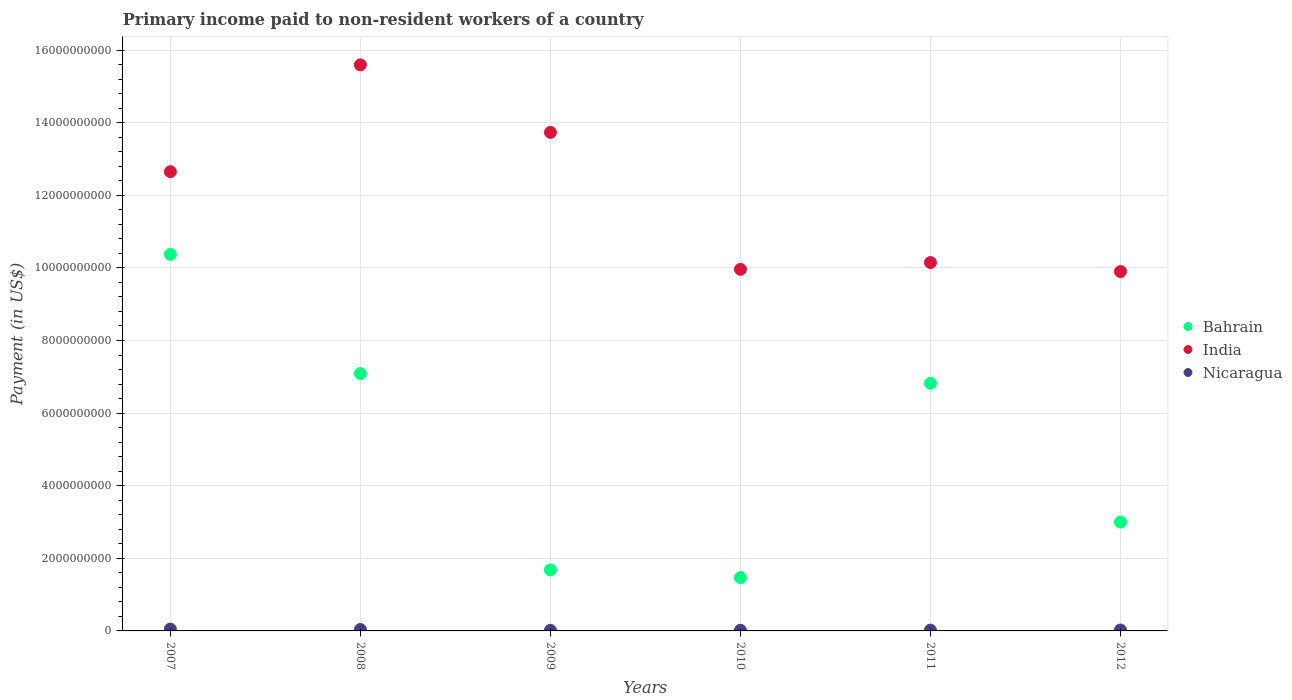What is the amount paid to workers in India in 2010?
Keep it short and to the point. 9.96e+09. Across all years, what is the maximum amount paid to workers in India?
Give a very brief answer. 1.56e+1. Across all years, what is the minimum amount paid to workers in India?
Keep it short and to the point. 9.90e+09. What is the total amount paid to workers in Bahrain in the graph?
Your answer should be very brief. 3.04e+1. What is the difference between the amount paid to workers in Bahrain in 2007 and that in 2011?
Give a very brief answer. 3.55e+09. What is the difference between the amount paid to workers in Nicaragua in 2011 and the amount paid to workers in India in 2010?
Offer a very short reply. -9.94e+09. What is the average amount paid to workers in India per year?
Offer a very short reply. 1.20e+1. In the year 2009, what is the difference between the amount paid to workers in Nicaragua and amount paid to workers in Bahrain?
Offer a terse response. -1.66e+09. In how many years, is the amount paid to workers in Bahrain greater than 5200000000 US$?
Give a very brief answer. 3. What is the ratio of the amount paid to workers in India in 2010 to that in 2011?
Give a very brief answer. 0.98. Is the amount paid to workers in Bahrain in 2010 less than that in 2011?
Provide a succinct answer. Yes. What is the difference between the highest and the second highest amount paid to workers in Nicaragua?
Ensure brevity in your answer.  9.20e+06. What is the difference between the highest and the lowest amount paid to workers in India?
Ensure brevity in your answer.  5.69e+09. In how many years, is the amount paid to workers in India greater than the average amount paid to workers in India taken over all years?
Offer a terse response. 3. Is the sum of the amount paid to workers in India in 2009 and 2011 greater than the maximum amount paid to workers in Bahrain across all years?
Keep it short and to the point. Yes. Does the amount paid to workers in Bahrain monotonically increase over the years?
Keep it short and to the point. No. Is the amount paid to workers in India strictly greater than the amount paid to workers in Nicaragua over the years?
Make the answer very short. Yes. Is the amount paid to workers in Bahrain strictly less than the amount paid to workers in Nicaragua over the years?
Offer a very short reply. No. How many dotlines are there?
Keep it short and to the point. 3. How many years are there in the graph?
Keep it short and to the point. 6. Are the values on the major ticks of Y-axis written in scientific E-notation?
Your answer should be compact. No. Where does the legend appear in the graph?
Your answer should be very brief. Center right. What is the title of the graph?
Provide a succinct answer. Primary income paid to non-resident workers of a country. What is the label or title of the X-axis?
Provide a succinct answer. Years. What is the label or title of the Y-axis?
Make the answer very short. Payment (in US$). What is the Payment (in US$) of Bahrain in 2007?
Make the answer very short. 1.04e+1. What is the Payment (in US$) in India in 2007?
Your response must be concise. 1.26e+1. What is the Payment (in US$) in Nicaragua in 2007?
Ensure brevity in your answer.  4.96e+07. What is the Payment (in US$) of Bahrain in 2008?
Give a very brief answer. 7.09e+09. What is the Payment (in US$) in India in 2008?
Offer a terse response. 1.56e+1. What is the Payment (in US$) in Nicaragua in 2008?
Provide a short and direct response. 4.04e+07. What is the Payment (in US$) of Bahrain in 2009?
Ensure brevity in your answer.  1.68e+09. What is the Payment (in US$) of India in 2009?
Provide a succinct answer. 1.37e+1. What is the Payment (in US$) of Nicaragua in 2009?
Make the answer very short. 1.73e+07. What is the Payment (in US$) of Bahrain in 2010?
Ensure brevity in your answer.  1.47e+09. What is the Payment (in US$) in India in 2010?
Provide a short and direct response. 9.96e+09. What is the Payment (in US$) in Nicaragua in 2010?
Keep it short and to the point. 1.82e+07. What is the Payment (in US$) of Bahrain in 2011?
Provide a short and direct response. 6.82e+09. What is the Payment (in US$) of India in 2011?
Your answer should be very brief. 1.01e+1. What is the Payment (in US$) of Nicaragua in 2011?
Provide a succinct answer. 2.16e+07. What is the Payment (in US$) of Bahrain in 2012?
Keep it short and to the point. 3.00e+09. What is the Payment (in US$) of India in 2012?
Your answer should be very brief. 9.90e+09. What is the Payment (in US$) in Nicaragua in 2012?
Your answer should be compact. 2.52e+07. Across all years, what is the maximum Payment (in US$) of Bahrain?
Give a very brief answer. 1.04e+1. Across all years, what is the maximum Payment (in US$) of India?
Your response must be concise. 1.56e+1. Across all years, what is the maximum Payment (in US$) in Nicaragua?
Provide a short and direct response. 4.96e+07. Across all years, what is the minimum Payment (in US$) of Bahrain?
Make the answer very short. 1.47e+09. Across all years, what is the minimum Payment (in US$) in India?
Your response must be concise. 9.90e+09. Across all years, what is the minimum Payment (in US$) of Nicaragua?
Your answer should be compact. 1.73e+07. What is the total Payment (in US$) in Bahrain in the graph?
Provide a short and direct response. 3.04e+1. What is the total Payment (in US$) in India in the graph?
Provide a short and direct response. 7.20e+1. What is the total Payment (in US$) of Nicaragua in the graph?
Your answer should be very brief. 1.72e+08. What is the difference between the Payment (in US$) in Bahrain in 2007 and that in 2008?
Make the answer very short. 3.29e+09. What is the difference between the Payment (in US$) in India in 2007 and that in 2008?
Your answer should be very brief. -2.94e+09. What is the difference between the Payment (in US$) of Nicaragua in 2007 and that in 2008?
Your answer should be compact. 9.20e+06. What is the difference between the Payment (in US$) of Bahrain in 2007 and that in 2009?
Ensure brevity in your answer.  8.69e+09. What is the difference between the Payment (in US$) in India in 2007 and that in 2009?
Offer a terse response. -1.08e+09. What is the difference between the Payment (in US$) in Nicaragua in 2007 and that in 2009?
Provide a short and direct response. 3.23e+07. What is the difference between the Payment (in US$) of Bahrain in 2007 and that in 2010?
Ensure brevity in your answer.  8.91e+09. What is the difference between the Payment (in US$) in India in 2007 and that in 2010?
Keep it short and to the point. 2.69e+09. What is the difference between the Payment (in US$) in Nicaragua in 2007 and that in 2010?
Your answer should be compact. 3.14e+07. What is the difference between the Payment (in US$) in Bahrain in 2007 and that in 2011?
Provide a succinct answer. 3.55e+09. What is the difference between the Payment (in US$) in India in 2007 and that in 2011?
Keep it short and to the point. 2.50e+09. What is the difference between the Payment (in US$) of Nicaragua in 2007 and that in 2011?
Make the answer very short. 2.80e+07. What is the difference between the Payment (in US$) of Bahrain in 2007 and that in 2012?
Provide a short and direct response. 7.38e+09. What is the difference between the Payment (in US$) in India in 2007 and that in 2012?
Offer a very short reply. 2.75e+09. What is the difference between the Payment (in US$) of Nicaragua in 2007 and that in 2012?
Your answer should be very brief. 2.44e+07. What is the difference between the Payment (in US$) of Bahrain in 2008 and that in 2009?
Keep it short and to the point. 5.41e+09. What is the difference between the Payment (in US$) of India in 2008 and that in 2009?
Your response must be concise. 1.86e+09. What is the difference between the Payment (in US$) in Nicaragua in 2008 and that in 2009?
Give a very brief answer. 2.31e+07. What is the difference between the Payment (in US$) of Bahrain in 2008 and that in 2010?
Offer a terse response. 5.62e+09. What is the difference between the Payment (in US$) in India in 2008 and that in 2010?
Provide a succinct answer. 5.63e+09. What is the difference between the Payment (in US$) in Nicaragua in 2008 and that in 2010?
Ensure brevity in your answer.  2.22e+07. What is the difference between the Payment (in US$) of Bahrain in 2008 and that in 2011?
Make the answer very short. 2.66e+08. What is the difference between the Payment (in US$) of India in 2008 and that in 2011?
Make the answer very short. 5.45e+09. What is the difference between the Payment (in US$) in Nicaragua in 2008 and that in 2011?
Make the answer very short. 1.88e+07. What is the difference between the Payment (in US$) in Bahrain in 2008 and that in 2012?
Keep it short and to the point. 4.09e+09. What is the difference between the Payment (in US$) in India in 2008 and that in 2012?
Provide a short and direct response. 5.69e+09. What is the difference between the Payment (in US$) in Nicaragua in 2008 and that in 2012?
Offer a terse response. 1.52e+07. What is the difference between the Payment (in US$) of Bahrain in 2009 and that in 2010?
Provide a short and direct response. 2.13e+08. What is the difference between the Payment (in US$) of India in 2009 and that in 2010?
Offer a terse response. 3.77e+09. What is the difference between the Payment (in US$) of Nicaragua in 2009 and that in 2010?
Your answer should be very brief. -9.00e+05. What is the difference between the Payment (in US$) in Bahrain in 2009 and that in 2011?
Offer a very short reply. -5.14e+09. What is the difference between the Payment (in US$) of India in 2009 and that in 2011?
Your answer should be compact. 3.59e+09. What is the difference between the Payment (in US$) of Nicaragua in 2009 and that in 2011?
Ensure brevity in your answer.  -4.30e+06. What is the difference between the Payment (in US$) of Bahrain in 2009 and that in 2012?
Offer a terse response. -1.32e+09. What is the difference between the Payment (in US$) in India in 2009 and that in 2012?
Provide a succinct answer. 3.83e+09. What is the difference between the Payment (in US$) of Nicaragua in 2009 and that in 2012?
Your answer should be very brief. -7.90e+06. What is the difference between the Payment (in US$) of Bahrain in 2010 and that in 2011?
Provide a succinct answer. -5.35e+09. What is the difference between the Payment (in US$) in India in 2010 and that in 2011?
Provide a succinct answer. -1.86e+08. What is the difference between the Payment (in US$) of Nicaragua in 2010 and that in 2011?
Ensure brevity in your answer.  -3.40e+06. What is the difference between the Payment (in US$) in Bahrain in 2010 and that in 2012?
Make the answer very short. -1.53e+09. What is the difference between the Payment (in US$) in India in 2010 and that in 2012?
Offer a terse response. 6.21e+07. What is the difference between the Payment (in US$) in Nicaragua in 2010 and that in 2012?
Keep it short and to the point. -7.00e+06. What is the difference between the Payment (in US$) of Bahrain in 2011 and that in 2012?
Your answer should be compact. 3.82e+09. What is the difference between the Payment (in US$) of India in 2011 and that in 2012?
Provide a short and direct response. 2.48e+08. What is the difference between the Payment (in US$) of Nicaragua in 2011 and that in 2012?
Your response must be concise. -3.60e+06. What is the difference between the Payment (in US$) of Bahrain in 2007 and the Payment (in US$) of India in 2008?
Your answer should be compact. -5.22e+09. What is the difference between the Payment (in US$) of Bahrain in 2007 and the Payment (in US$) of Nicaragua in 2008?
Offer a very short reply. 1.03e+1. What is the difference between the Payment (in US$) in India in 2007 and the Payment (in US$) in Nicaragua in 2008?
Your response must be concise. 1.26e+1. What is the difference between the Payment (in US$) in Bahrain in 2007 and the Payment (in US$) in India in 2009?
Keep it short and to the point. -3.36e+09. What is the difference between the Payment (in US$) in Bahrain in 2007 and the Payment (in US$) in Nicaragua in 2009?
Offer a terse response. 1.04e+1. What is the difference between the Payment (in US$) in India in 2007 and the Payment (in US$) in Nicaragua in 2009?
Your answer should be very brief. 1.26e+1. What is the difference between the Payment (in US$) of Bahrain in 2007 and the Payment (in US$) of India in 2010?
Offer a very short reply. 4.13e+08. What is the difference between the Payment (in US$) of Bahrain in 2007 and the Payment (in US$) of Nicaragua in 2010?
Offer a terse response. 1.04e+1. What is the difference between the Payment (in US$) of India in 2007 and the Payment (in US$) of Nicaragua in 2010?
Offer a very short reply. 1.26e+1. What is the difference between the Payment (in US$) of Bahrain in 2007 and the Payment (in US$) of India in 2011?
Ensure brevity in your answer.  2.26e+08. What is the difference between the Payment (in US$) of Bahrain in 2007 and the Payment (in US$) of Nicaragua in 2011?
Your answer should be very brief. 1.04e+1. What is the difference between the Payment (in US$) in India in 2007 and the Payment (in US$) in Nicaragua in 2011?
Offer a terse response. 1.26e+1. What is the difference between the Payment (in US$) in Bahrain in 2007 and the Payment (in US$) in India in 2012?
Offer a terse response. 4.75e+08. What is the difference between the Payment (in US$) of Bahrain in 2007 and the Payment (in US$) of Nicaragua in 2012?
Your answer should be compact. 1.03e+1. What is the difference between the Payment (in US$) in India in 2007 and the Payment (in US$) in Nicaragua in 2012?
Offer a terse response. 1.26e+1. What is the difference between the Payment (in US$) of Bahrain in 2008 and the Payment (in US$) of India in 2009?
Make the answer very short. -6.64e+09. What is the difference between the Payment (in US$) in Bahrain in 2008 and the Payment (in US$) in Nicaragua in 2009?
Your response must be concise. 7.07e+09. What is the difference between the Payment (in US$) in India in 2008 and the Payment (in US$) in Nicaragua in 2009?
Offer a very short reply. 1.56e+1. What is the difference between the Payment (in US$) in Bahrain in 2008 and the Payment (in US$) in India in 2010?
Keep it short and to the point. -2.87e+09. What is the difference between the Payment (in US$) in Bahrain in 2008 and the Payment (in US$) in Nicaragua in 2010?
Your response must be concise. 7.07e+09. What is the difference between the Payment (in US$) in India in 2008 and the Payment (in US$) in Nicaragua in 2010?
Offer a very short reply. 1.56e+1. What is the difference between the Payment (in US$) in Bahrain in 2008 and the Payment (in US$) in India in 2011?
Your response must be concise. -3.06e+09. What is the difference between the Payment (in US$) in Bahrain in 2008 and the Payment (in US$) in Nicaragua in 2011?
Make the answer very short. 7.07e+09. What is the difference between the Payment (in US$) in India in 2008 and the Payment (in US$) in Nicaragua in 2011?
Offer a very short reply. 1.56e+1. What is the difference between the Payment (in US$) in Bahrain in 2008 and the Payment (in US$) in India in 2012?
Provide a succinct answer. -2.81e+09. What is the difference between the Payment (in US$) in Bahrain in 2008 and the Payment (in US$) in Nicaragua in 2012?
Your answer should be very brief. 7.06e+09. What is the difference between the Payment (in US$) of India in 2008 and the Payment (in US$) of Nicaragua in 2012?
Offer a very short reply. 1.56e+1. What is the difference between the Payment (in US$) in Bahrain in 2009 and the Payment (in US$) in India in 2010?
Offer a very short reply. -8.28e+09. What is the difference between the Payment (in US$) in Bahrain in 2009 and the Payment (in US$) in Nicaragua in 2010?
Offer a very short reply. 1.66e+09. What is the difference between the Payment (in US$) of India in 2009 and the Payment (in US$) of Nicaragua in 2010?
Provide a short and direct response. 1.37e+1. What is the difference between the Payment (in US$) in Bahrain in 2009 and the Payment (in US$) in India in 2011?
Your response must be concise. -8.47e+09. What is the difference between the Payment (in US$) in Bahrain in 2009 and the Payment (in US$) in Nicaragua in 2011?
Ensure brevity in your answer.  1.66e+09. What is the difference between the Payment (in US$) of India in 2009 and the Payment (in US$) of Nicaragua in 2011?
Provide a short and direct response. 1.37e+1. What is the difference between the Payment (in US$) in Bahrain in 2009 and the Payment (in US$) in India in 2012?
Your answer should be very brief. -8.22e+09. What is the difference between the Payment (in US$) of Bahrain in 2009 and the Payment (in US$) of Nicaragua in 2012?
Your answer should be very brief. 1.65e+09. What is the difference between the Payment (in US$) of India in 2009 and the Payment (in US$) of Nicaragua in 2012?
Your answer should be very brief. 1.37e+1. What is the difference between the Payment (in US$) of Bahrain in 2010 and the Payment (in US$) of India in 2011?
Offer a very short reply. -8.68e+09. What is the difference between the Payment (in US$) in Bahrain in 2010 and the Payment (in US$) in Nicaragua in 2011?
Provide a succinct answer. 1.45e+09. What is the difference between the Payment (in US$) of India in 2010 and the Payment (in US$) of Nicaragua in 2011?
Ensure brevity in your answer.  9.94e+09. What is the difference between the Payment (in US$) in Bahrain in 2010 and the Payment (in US$) in India in 2012?
Provide a succinct answer. -8.43e+09. What is the difference between the Payment (in US$) of Bahrain in 2010 and the Payment (in US$) of Nicaragua in 2012?
Provide a short and direct response. 1.44e+09. What is the difference between the Payment (in US$) of India in 2010 and the Payment (in US$) of Nicaragua in 2012?
Ensure brevity in your answer.  9.94e+09. What is the difference between the Payment (in US$) of Bahrain in 2011 and the Payment (in US$) of India in 2012?
Your answer should be very brief. -3.08e+09. What is the difference between the Payment (in US$) in Bahrain in 2011 and the Payment (in US$) in Nicaragua in 2012?
Your answer should be compact. 6.80e+09. What is the difference between the Payment (in US$) in India in 2011 and the Payment (in US$) in Nicaragua in 2012?
Provide a short and direct response. 1.01e+1. What is the average Payment (in US$) in Bahrain per year?
Your answer should be very brief. 5.07e+09. What is the average Payment (in US$) in India per year?
Ensure brevity in your answer.  1.20e+1. What is the average Payment (in US$) of Nicaragua per year?
Make the answer very short. 2.87e+07. In the year 2007, what is the difference between the Payment (in US$) of Bahrain and Payment (in US$) of India?
Ensure brevity in your answer.  -2.28e+09. In the year 2007, what is the difference between the Payment (in US$) in Bahrain and Payment (in US$) in Nicaragua?
Your answer should be very brief. 1.03e+1. In the year 2007, what is the difference between the Payment (in US$) in India and Payment (in US$) in Nicaragua?
Offer a very short reply. 1.26e+1. In the year 2008, what is the difference between the Payment (in US$) in Bahrain and Payment (in US$) in India?
Your answer should be very brief. -8.51e+09. In the year 2008, what is the difference between the Payment (in US$) in Bahrain and Payment (in US$) in Nicaragua?
Make the answer very short. 7.05e+09. In the year 2008, what is the difference between the Payment (in US$) in India and Payment (in US$) in Nicaragua?
Offer a terse response. 1.56e+1. In the year 2009, what is the difference between the Payment (in US$) of Bahrain and Payment (in US$) of India?
Make the answer very short. -1.21e+1. In the year 2009, what is the difference between the Payment (in US$) in Bahrain and Payment (in US$) in Nicaragua?
Your answer should be compact. 1.66e+09. In the year 2009, what is the difference between the Payment (in US$) of India and Payment (in US$) of Nicaragua?
Provide a short and direct response. 1.37e+1. In the year 2010, what is the difference between the Payment (in US$) in Bahrain and Payment (in US$) in India?
Make the answer very short. -8.49e+09. In the year 2010, what is the difference between the Payment (in US$) of Bahrain and Payment (in US$) of Nicaragua?
Your answer should be compact. 1.45e+09. In the year 2010, what is the difference between the Payment (in US$) in India and Payment (in US$) in Nicaragua?
Ensure brevity in your answer.  9.94e+09. In the year 2011, what is the difference between the Payment (in US$) in Bahrain and Payment (in US$) in India?
Make the answer very short. -3.33e+09. In the year 2011, what is the difference between the Payment (in US$) in Bahrain and Payment (in US$) in Nicaragua?
Offer a very short reply. 6.80e+09. In the year 2011, what is the difference between the Payment (in US$) in India and Payment (in US$) in Nicaragua?
Your response must be concise. 1.01e+1. In the year 2012, what is the difference between the Payment (in US$) of Bahrain and Payment (in US$) of India?
Make the answer very short. -6.90e+09. In the year 2012, what is the difference between the Payment (in US$) in Bahrain and Payment (in US$) in Nicaragua?
Offer a terse response. 2.97e+09. In the year 2012, what is the difference between the Payment (in US$) of India and Payment (in US$) of Nicaragua?
Make the answer very short. 9.87e+09. What is the ratio of the Payment (in US$) of Bahrain in 2007 to that in 2008?
Provide a succinct answer. 1.46. What is the ratio of the Payment (in US$) in India in 2007 to that in 2008?
Your answer should be compact. 0.81. What is the ratio of the Payment (in US$) of Nicaragua in 2007 to that in 2008?
Offer a very short reply. 1.23. What is the ratio of the Payment (in US$) in Bahrain in 2007 to that in 2009?
Offer a terse response. 6.17. What is the ratio of the Payment (in US$) in India in 2007 to that in 2009?
Your answer should be very brief. 0.92. What is the ratio of the Payment (in US$) of Nicaragua in 2007 to that in 2009?
Provide a short and direct response. 2.87. What is the ratio of the Payment (in US$) in Bahrain in 2007 to that in 2010?
Make the answer very short. 7.07. What is the ratio of the Payment (in US$) in India in 2007 to that in 2010?
Offer a terse response. 1.27. What is the ratio of the Payment (in US$) of Nicaragua in 2007 to that in 2010?
Offer a terse response. 2.73. What is the ratio of the Payment (in US$) in Bahrain in 2007 to that in 2011?
Offer a very short reply. 1.52. What is the ratio of the Payment (in US$) in India in 2007 to that in 2011?
Your answer should be very brief. 1.25. What is the ratio of the Payment (in US$) of Nicaragua in 2007 to that in 2011?
Keep it short and to the point. 2.3. What is the ratio of the Payment (in US$) in Bahrain in 2007 to that in 2012?
Ensure brevity in your answer.  3.46. What is the ratio of the Payment (in US$) of India in 2007 to that in 2012?
Your answer should be compact. 1.28. What is the ratio of the Payment (in US$) of Nicaragua in 2007 to that in 2012?
Your answer should be very brief. 1.97. What is the ratio of the Payment (in US$) in Bahrain in 2008 to that in 2009?
Your answer should be very brief. 4.22. What is the ratio of the Payment (in US$) in India in 2008 to that in 2009?
Your answer should be compact. 1.14. What is the ratio of the Payment (in US$) of Nicaragua in 2008 to that in 2009?
Your response must be concise. 2.34. What is the ratio of the Payment (in US$) in Bahrain in 2008 to that in 2010?
Provide a succinct answer. 4.83. What is the ratio of the Payment (in US$) in India in 2008 to that in 2010?
Ensure brevity in your answer.  1.57. What is the ratio of the Payment (in US$) in Nicaragua in 2008 to that in 2010?
Offer a terse response. 2.22. What is the ratio of the Payment (in US$) in Bahrain in 2008 to that in 2011?
Your answer should be compact. 1.04. What is the ratio of the Payment (in US$) in India in 2008 to that in 2011?
Offer a very short reply. 1.54. What is the ratio of the Payment (in US$) of Nicaragua in 2008 to that in 2011?
Your response must be concise. 1.87. What is the ratio of the Payment (in US$) in Bahrain in 2008 to that in 2012?
Your response must be concise. 2.36. What is the ratio of the Payment (in US$) in India in 2008 to that in 2012?
Ensure brevity in your answer.  1.58. What is the ratio of the Payment (in US$) of Nicaragua in 2008 to that in 2012?
Ensure brevity in your answer.  1.6. What is the ratio of the Payment (in US$) of Bahrain in 2009 to that in 2010?
Provide a succinct answer. 1.14. What is the ratio of the Payment (in US$) of India in 2009 to that in 2010?
Your answer should be compact. 1.38. What is the ratio of the Payment (in US$) in Nicaragua in 2009 to that in 2010?
Keep it short and to the point. 0.95. What is the ratio of the Payment (in US$) in Bahrain in 2009 to that in 2011?
Provide a short and direct response. 0.25. What is the ratio of the Payment (in US$) of India in 2009 to that in 2011?
Your answer should be very brief. 1.35. What is the ratio of the Payment (in US$) in Nicaragua in 2009 to that in 2011?
Make the answer very short. 0.8. What is the ratio of the Payment (in US$) of Bahrain in 2009 to that in 2012?
Make the answer very short. 0.56. What is the ratio of the Payment (in US$) in India in 2009 to that in 2012?
Your response must be concise. 1.39. What is the ratio of the Payment (in US$) in Nicaragua in 2009 to that in 2012?
Your response must be concise. 0.69. What is the ratio of the Payment (in US$) in Bahrain in 2010 to that in 2011?
Keep it short and to the point. 0.22. What is the ratio of the Payment (in US$) of India in 2010 to that in 2011?
Provide a succinct answer. 0.98. What is the ratio of the Payment (in US$) in Nicaragua in 2010 to that in 2011?
Keep it short and to the point. 0.84. What is the ratio of the Payment (in US$) of Bahrain in 2010 to that in 2012?
Keep it short and to the point. 0.49. What is the ratio of the Payment (in US$) in India in 2010 to that in 2012?
Your response must be concise. 1.01. What is the ratio of the Payment (in US$) of Nicaragua in 2010 to that in 2012?
Make the answer very short. 0.72. What is the ratio of the Payment (in US$) of Bahrain in 2011 to that in 2012?
Offer a terse response. 2.28. What is the ratio of the Payment (in US$) in India in 2011 to that in 2012?
Ensure brevity in your answer.  1.03. What is the difference between the highest and the second highest Payment (in US$) in Bahrain?
Provide a succinct answer. 3.29e+09. What is the difference between the highest and the second highest Payment (in US$) of India?
Make the answer very short. 1.86e+09. What is the difference between the highest and the second highest Payment (in US$) in Nicaragua?
Keep it short and to the point. 9.20e+06. What is the difference between the highest and the lowest Payment (in US$) of Bahrain?
Make the answer very short. 8.91e+09. What is the difference between the highest and the lowest Payment (in US$) of India?
Provide a succinct answer. 5.69e+09. What is the difference between the highest and the lowest Payment (in US$) in Nicaragua?
Offer a very short reply. 3.23e+07. 